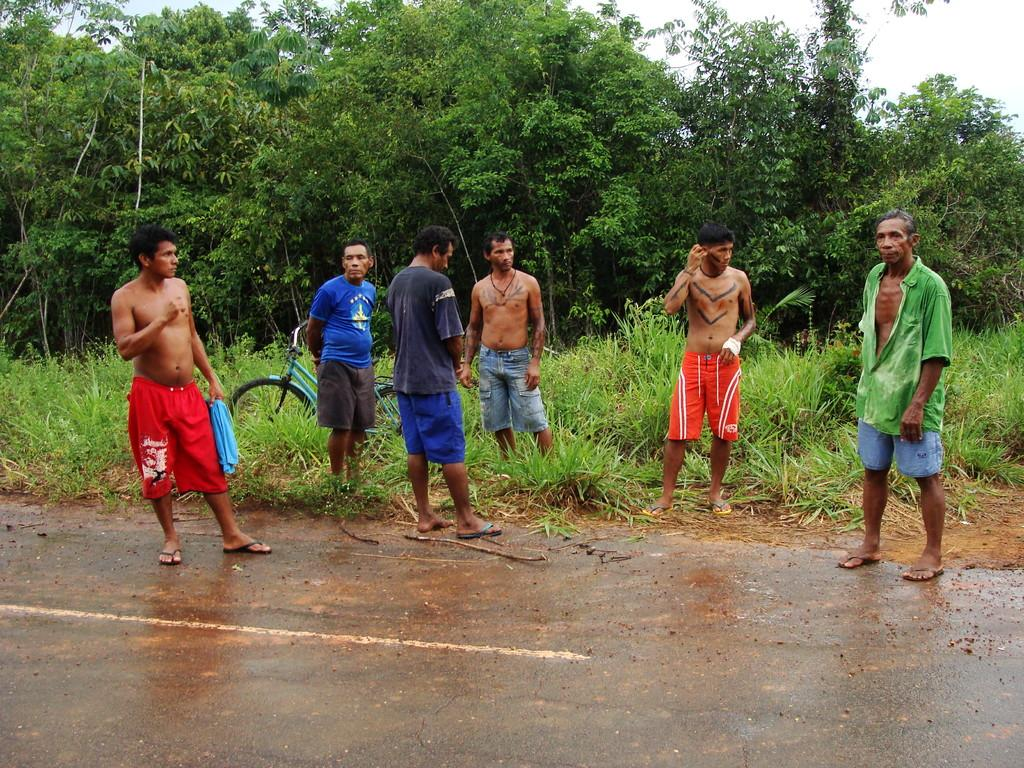How many people are in the image? There is a group of persons standing in the image. What is the ground surface like in the background of the image? There is grass on the ground in the background of the image. What type of vehicle is present in the image? There is a bicycle in the image. What type of vegetation can be seen in the background of the image? There are trees in the background of the image. How many cats are sitting on the bridge in the image? There is no bridge or cats present in the image. 